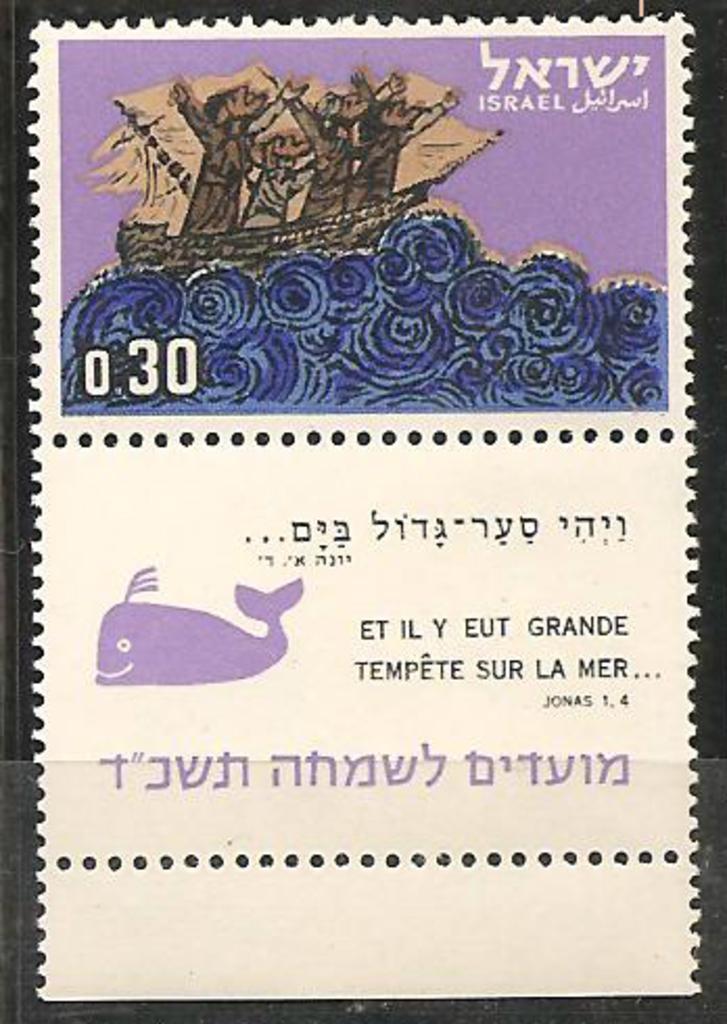In one or two sentences, can you explain what this image depicts? This picture is consists of a poster in the image. 